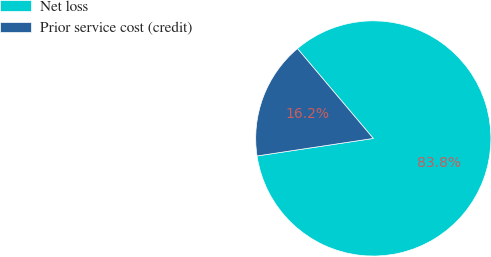Convert chart. <chart><loc_0><loc_0><loc_500><loc_500><pie_chart><fcel>Net loss<fcel>Prior service cost (credit)<nl><fcel>83.78%<fcel>16.22%<nl></chart> 